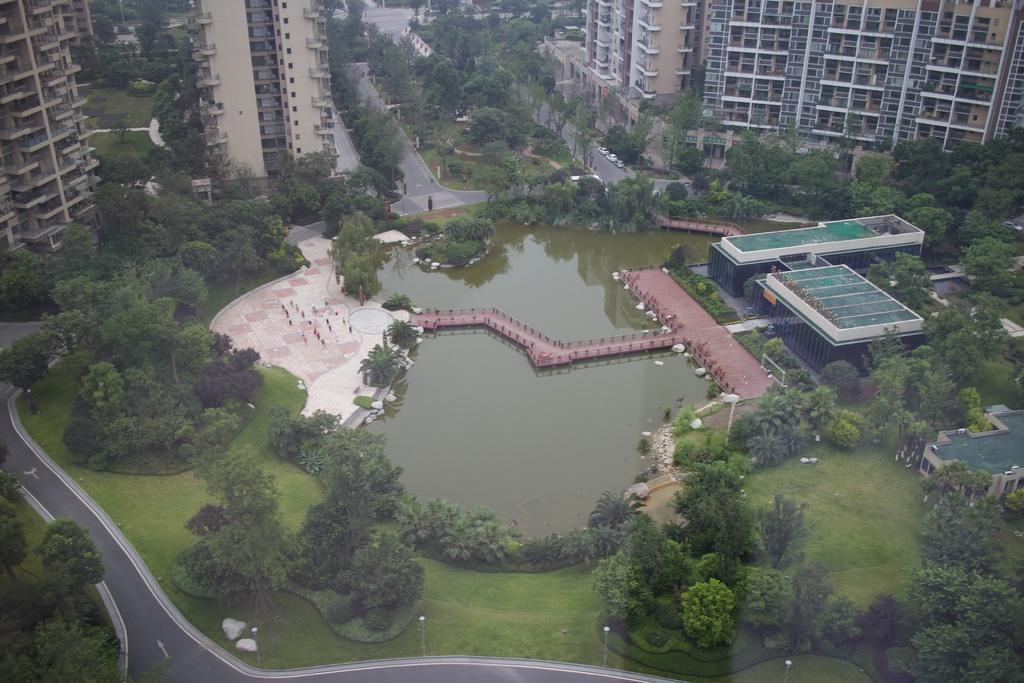Could you give a brief overview of what you see in this image? In the image we can see there are many buildings and trees. Here we can see grass, water, path, road, and poles. 